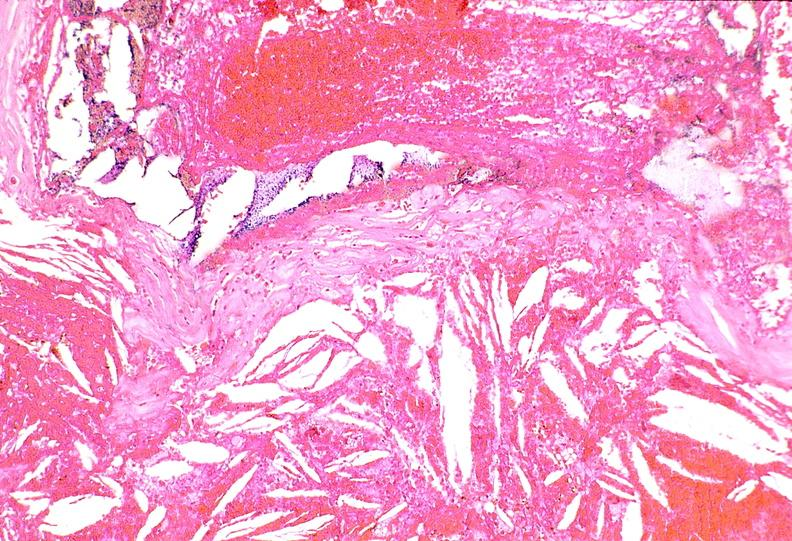where is this from?
Answer the question using a single word or phrase. Vasculature 